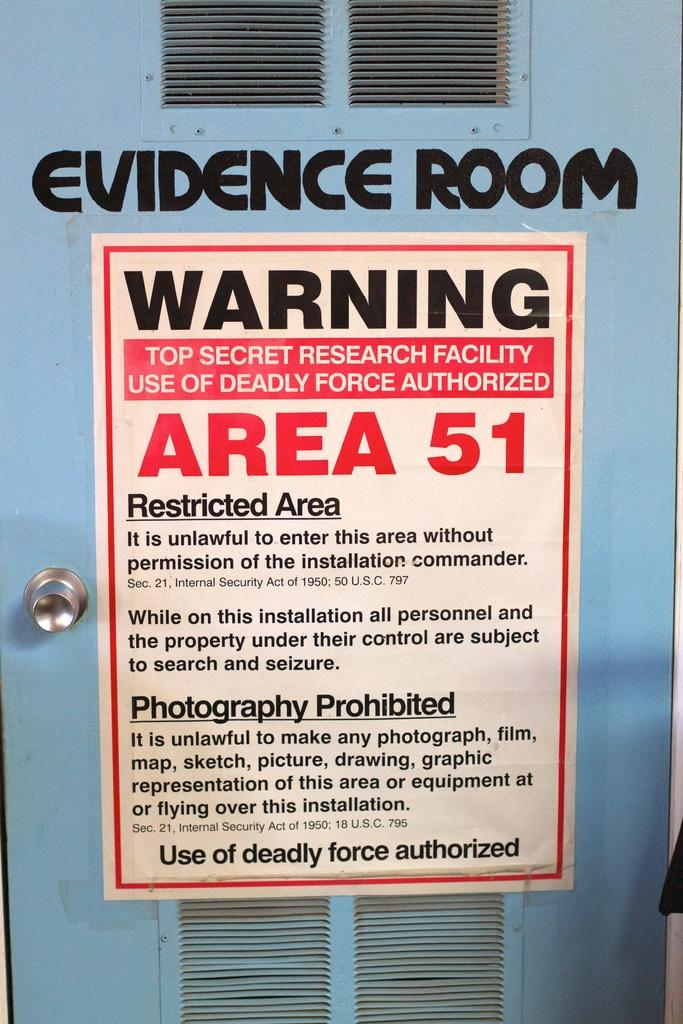<image>
Render a clear and concise summary of the photo. A door to the evidence room at Area 51 with a warning. 